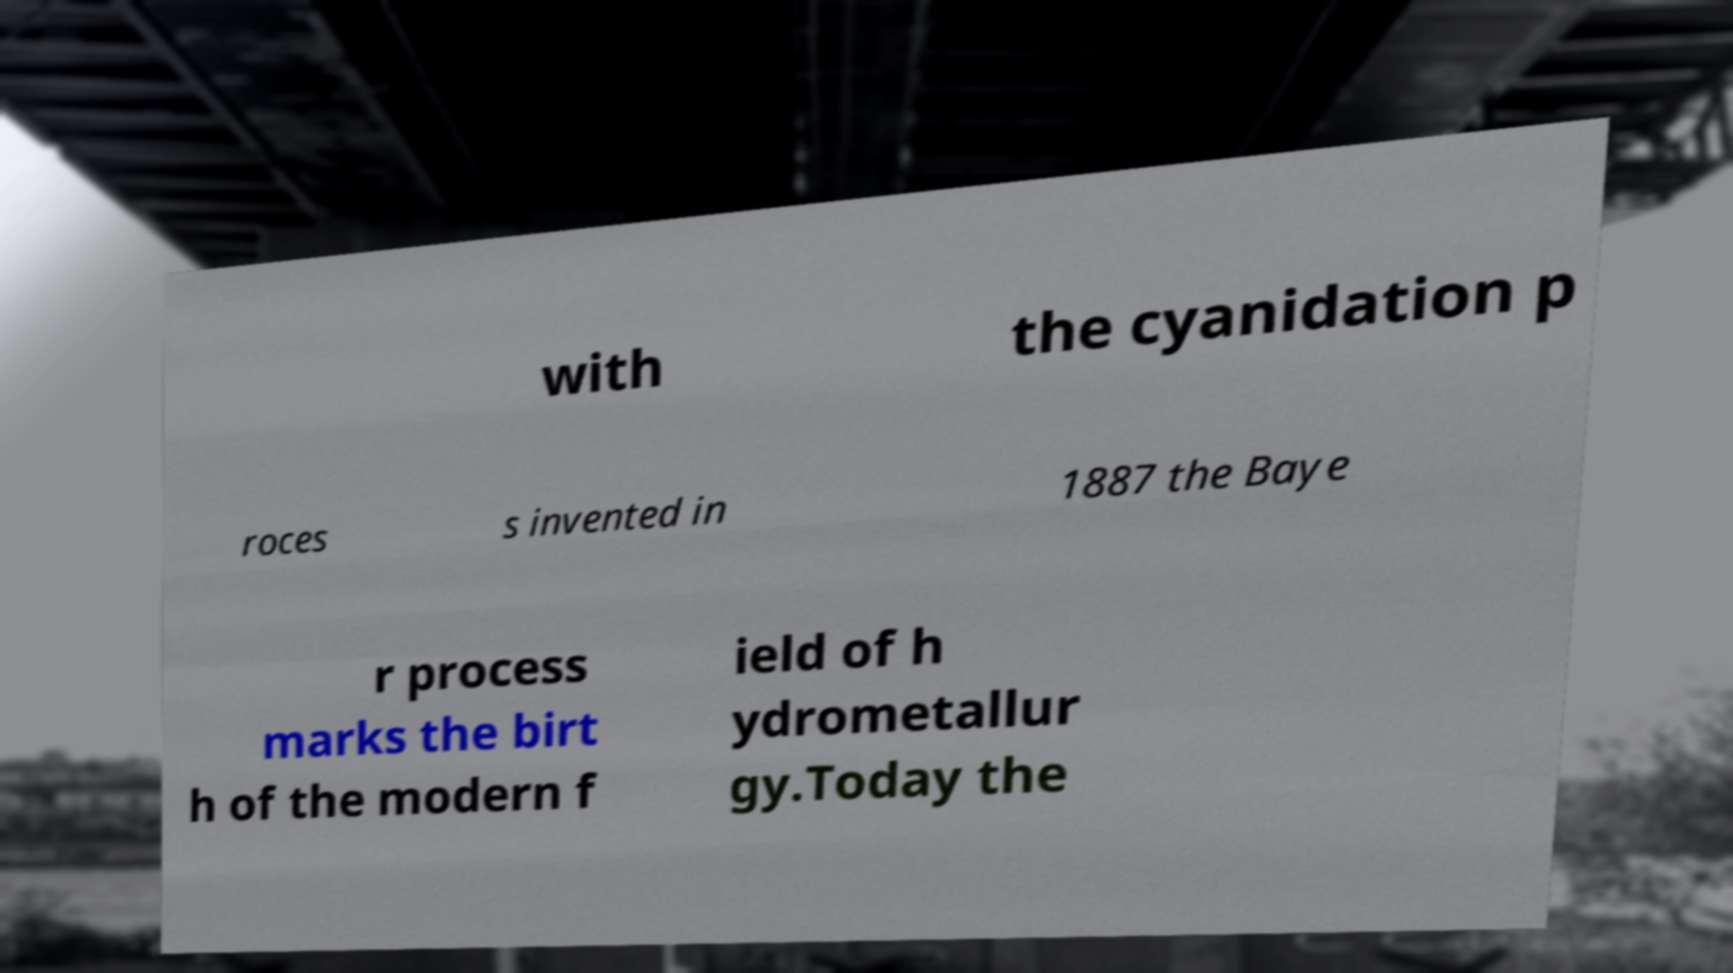Can you accurately transcribe the text from the provided image for me? with the cyanidation p roces s invented in 1887 the Baye r process marks the birt h of the modern f ield of h ydrometallur gy.Today the 